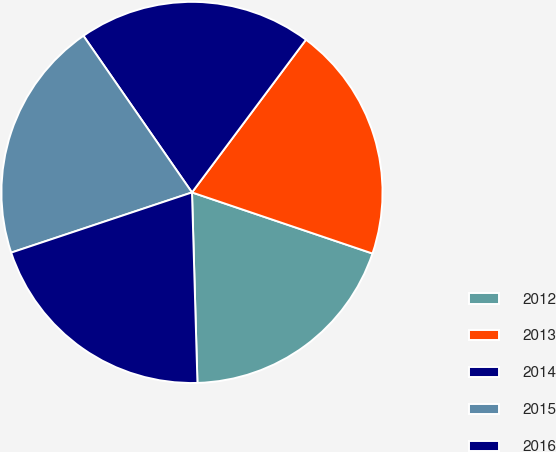Convert chart. <chart><loc_0><loc_0><loc_500><loc_500><pie_chart><fcel>2012<fcel>2013<fcel>2014<fcel>2015<fcel>2016<nl><fcel>19.35%<fcel>19.99%<fcel>19.85%<fcel>20.47%<fcel>20.34%<nl></chart> 